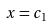Convert formula to latex. <formula><loc_0><loc_0><loc_500><loc_500>x = c _ { 1 }</formula> 